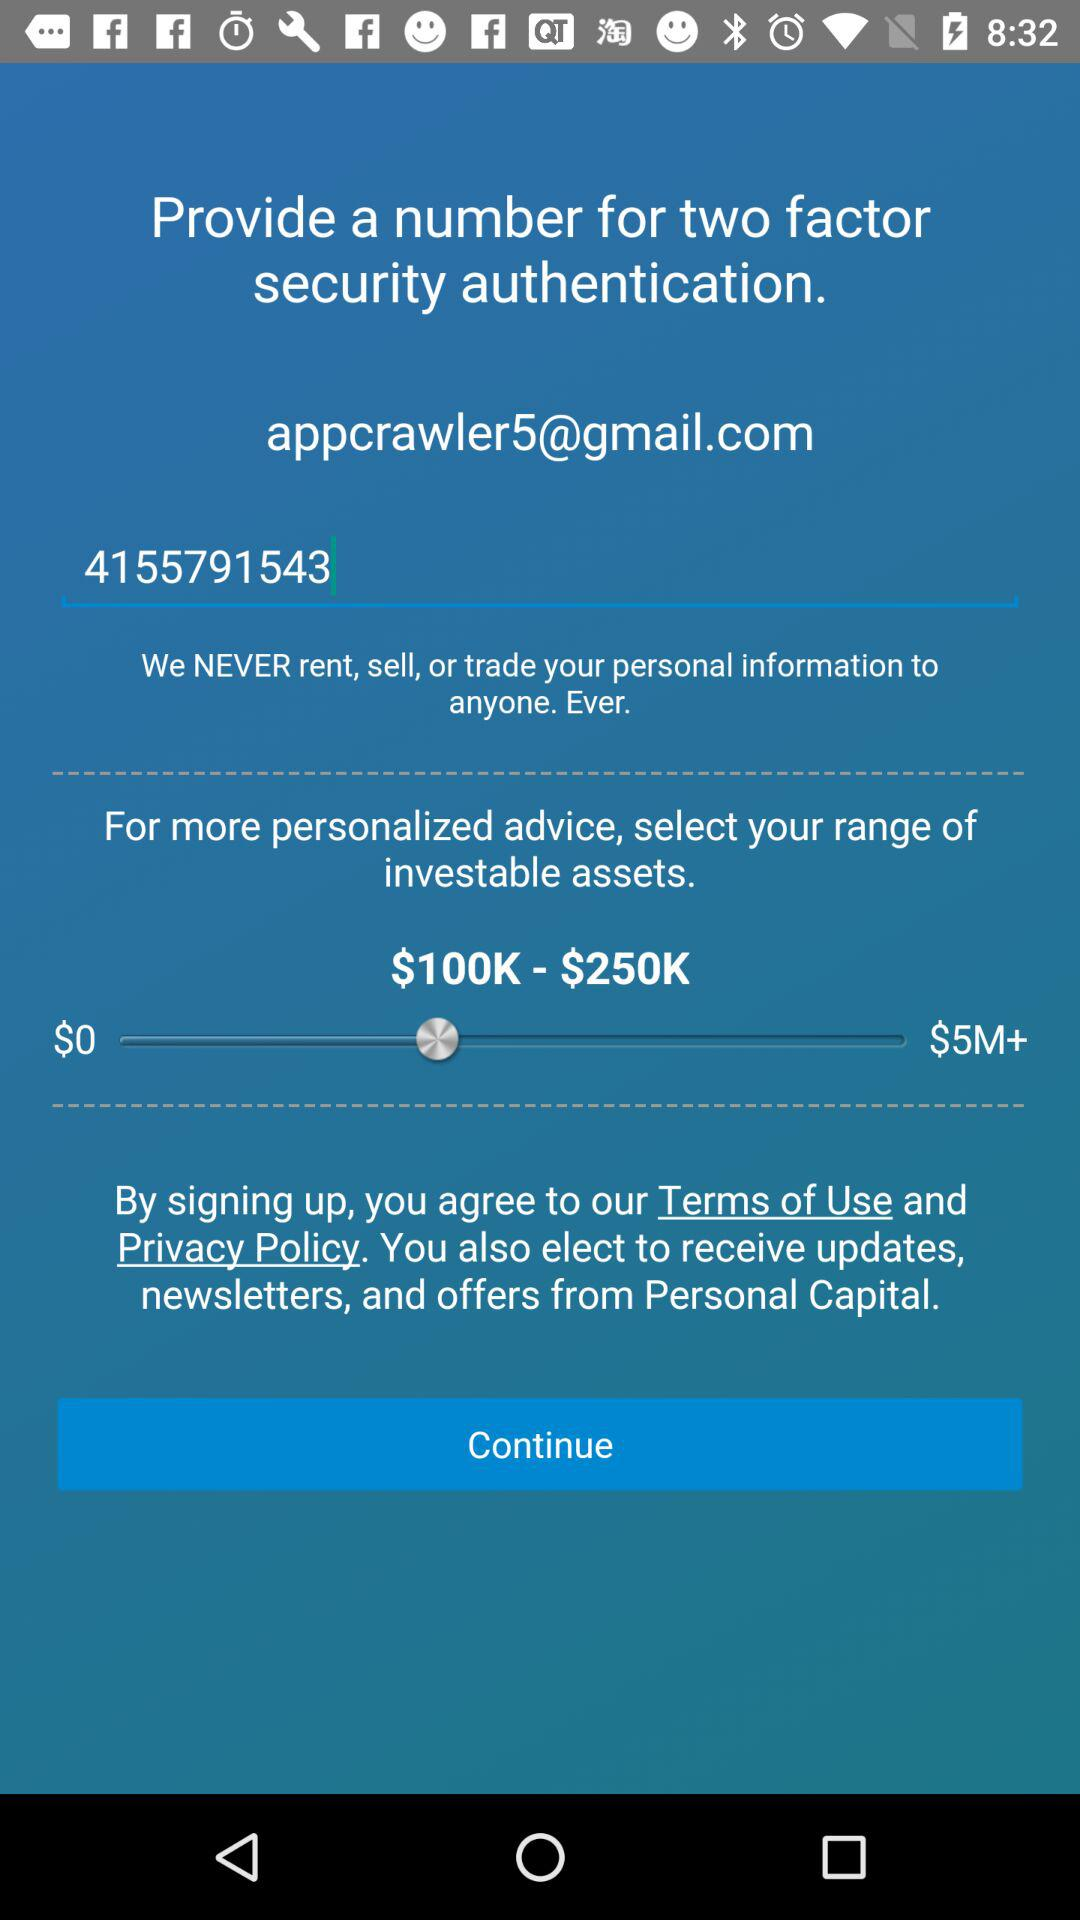What is the range of investable assets? The range of investable assets is from $100K to $250K. 